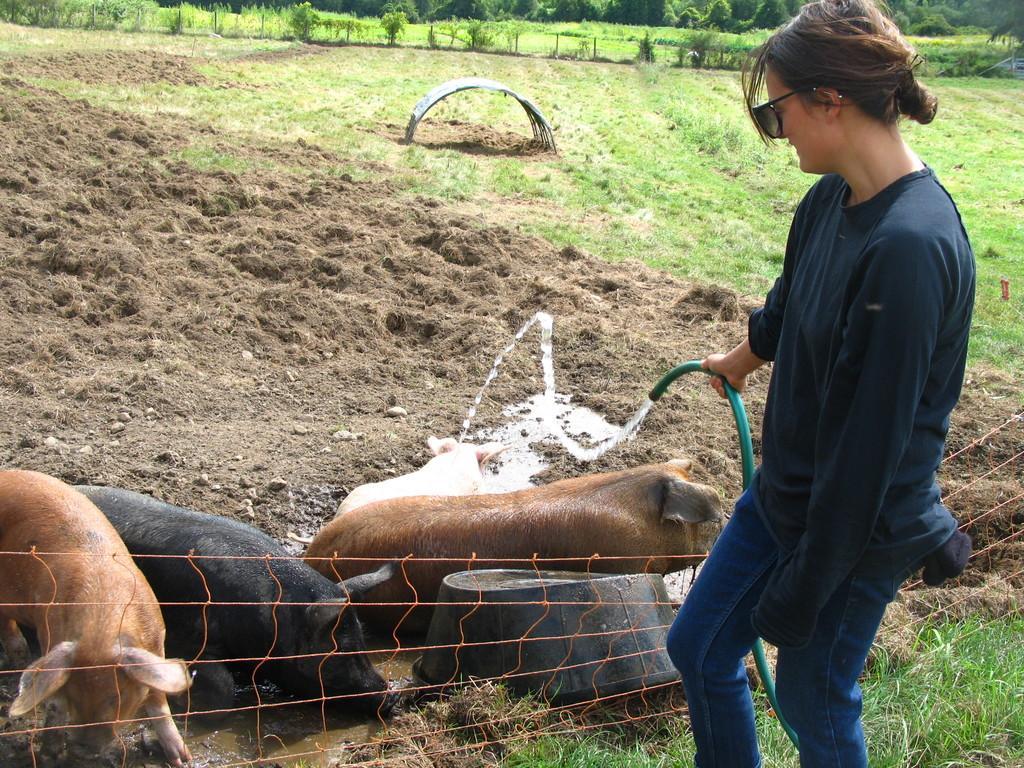Can you describe this image briefly? In this image I can see the person wearing the blue color dress and also goggles. I can see the person holding the water pipe. To the side of the person there are few animals which are in brown, black and white color. In the background I can see many trees. 